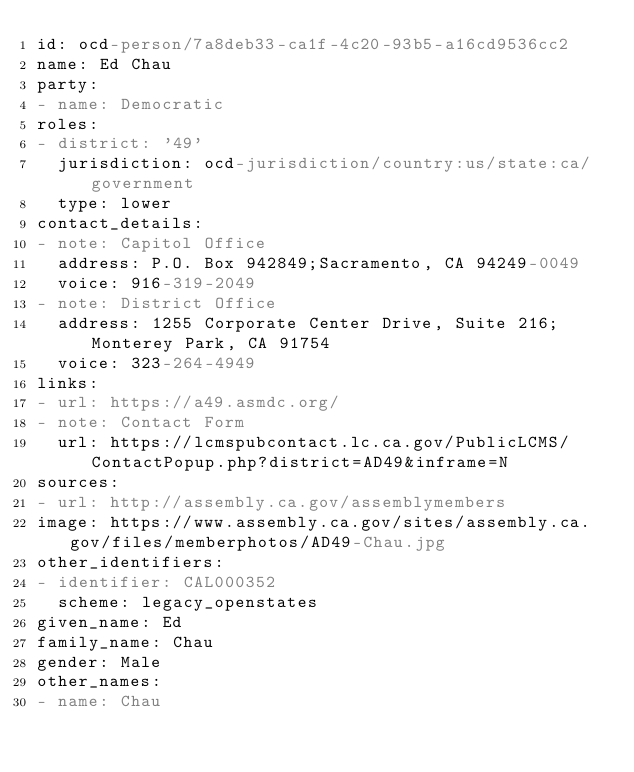<code> <loc_0><loc_0><loc_500><loc_500><_YAML_>id: ocd-person/7a8deb33-ca1f-4c20-93b5-a16cd9536cc2
name: Ed Chau
party:
- name: Democratic
roles:
- district: '49'
  jurisdiction: ocd-jurisdiction/country:us/state:ca/government
  type: lower
contact_details:
- note: Capitol Office
  address: P.O. Box 942849;Sacramento, CA 94249-0049
  voice: 916-319-2049
- note: District Office
  address: 1255 Corporate Center Drive, Suite 216;Monterey Park, CA 91754
  voice: 323-264-4949
links:
- url: https://a49.asmdc.org/
- note: Contact Form
  url: https://lcmspubcontact.lc.ca.gov/PublicLCMS/ContactPopup.php?district=AD49&inframe=N
sources:
- url: http://assembly.ca.gov/assemblymembers
image: https://www.assembly.ca.gov/sites/assembly.ca.gov/files/memberphotos/AD49-Chau.jpg
other_identifiers:
- identifier: CAL000352
  scheme: legacy_openstates
given_name: Ed
family_name: Chau
gender: Male
other_names:
- name: Chau
</code> 